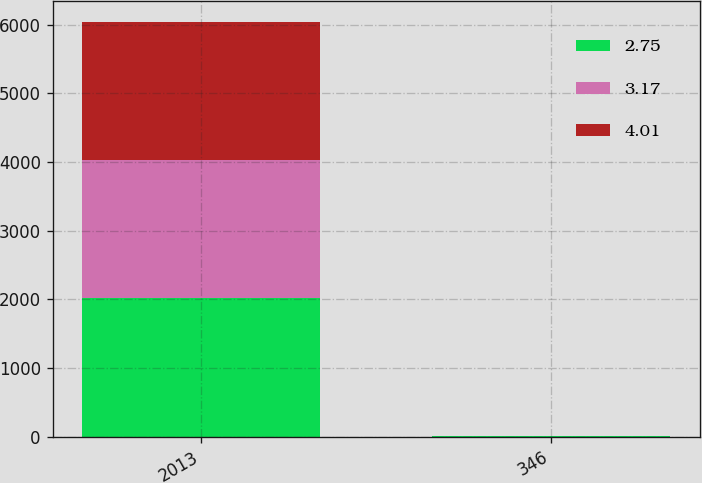Convert chart to OTSL. <chart><loc_0><loc_0><loc_500><loc_500><stacked_bar_chart><ecel><fcel>2013<fcel>346<nl><fcel>2.75<fcel>2013<fcel>2.75<nl><fcel>3.17<fcel>2012<fcel>4.01<nl><fcel>4.01<fcel>2012<fcel>3.17<nl></chart> 